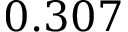Convert formula to latex. <formula><loc_0><loc_0><loc_500><loc_500>0 . 3 0 7</formula> 